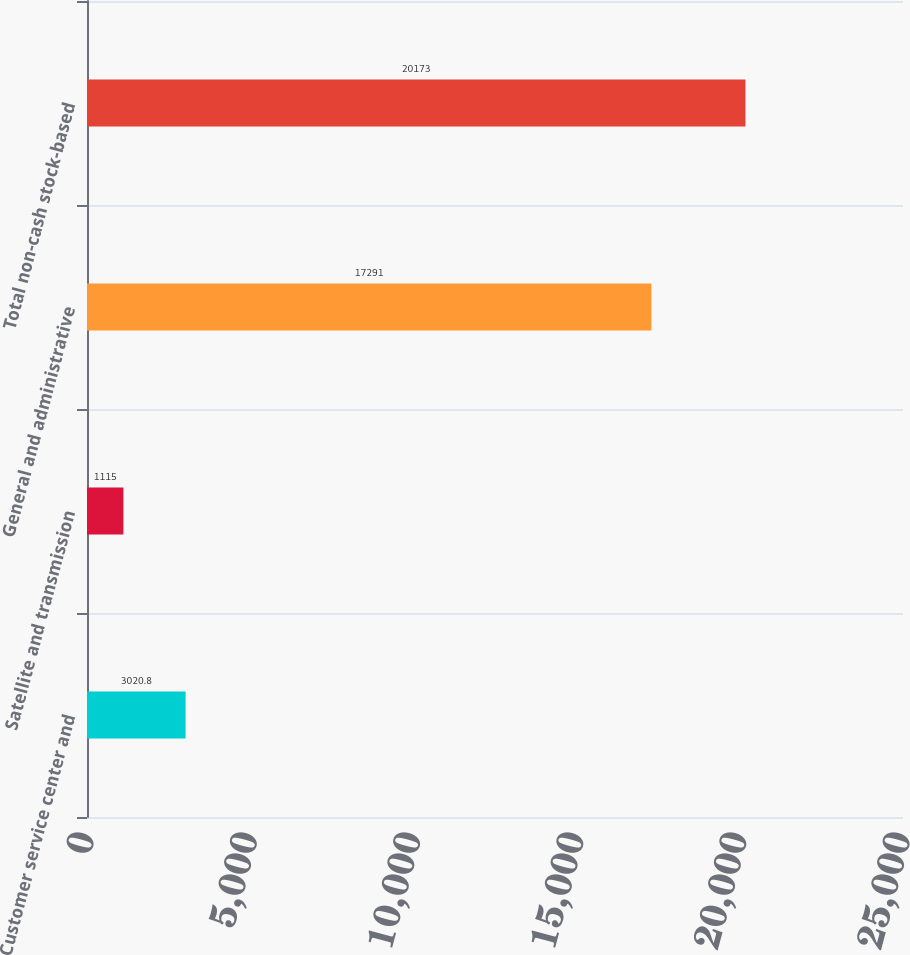Convert chart to OTSL. <chart><loc_0><loc_0><loc_500><loc_500><bar_chart><fcel>Customer service center and<fcel>Satellite and transmission<fcel>General and administrative<fcel>Total non-cash stock-based<nl><fcel>3020.8<fcel>1115<fcel>17291<fcel>20173<nl></chart> 